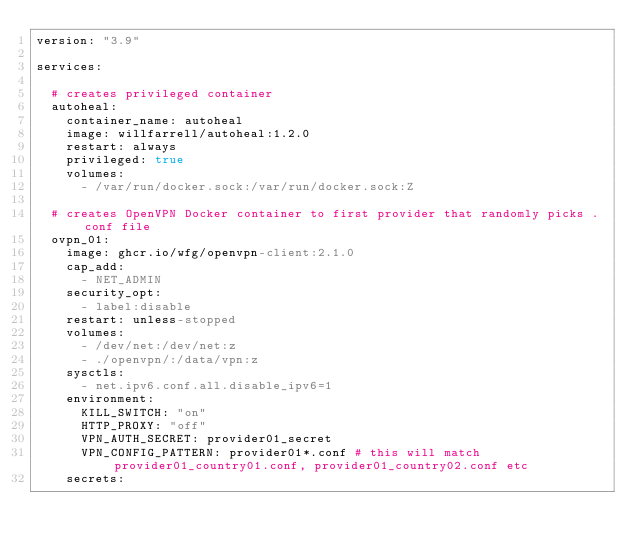<code> <loc_0><loc_0><loc_500><loc_500><_YAML_>version: "3.9"

services:

  # creates privileged container
  autoheal:
    container_name: autoheal
    image: willfarrell/autoheal:1.2.0
    restart: always
    privileged: true
    volumes:
      - /var/run/docker.sock:/var/run/docker.sock:Z

  # creates OpenVPN Docker container to first provider that randomly picks .conf file
  ovpn_01:
    image: ghcr.io/wfg/openvpn-client:2.1.0
    cap_add:
      - NET_ADMIN
    security_opt:
      - label:disable
    restart: unless-stopped
    volumes:
      - /dev/net:/dev/net:z
      - ./openvpn/:/data/vpn:z
    sysctls:
      - net.ipv6.conf.all.disable_ipv6=1
    environment:
      KILL_SWITCH: "on"
      HTTP_PROXY: "off"
      VPN_AUTH_SECRET: provider01_secret
      VPN_CONFIG_PATTERN: provider01*.conf # this will match provider01_country01.conf, provider01_country02.conf etc
    secrets:</code> 